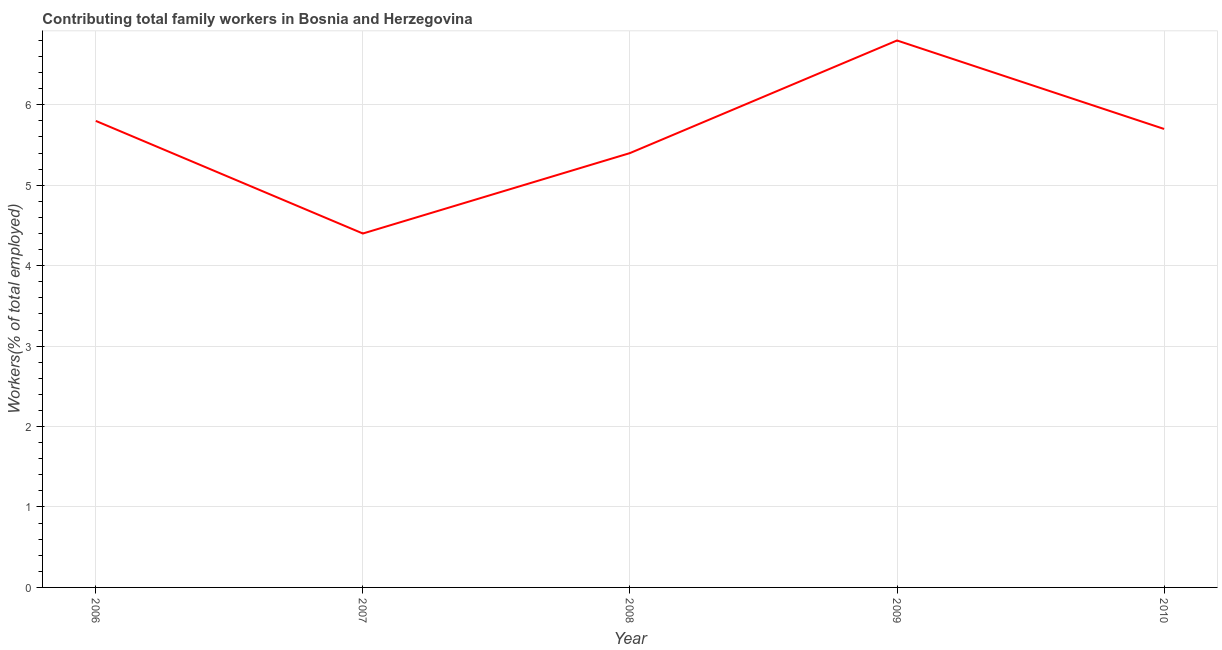What is the contributing family workers in 2006?
Ensure brevity in your answer.  5.8. Across all years, what is the maximum contributing family workers?
Your answer should be compact. 6.8. Across all years, what is the minimum contributing family workers?
Ensure brevity in your answer.  4.4. In which year was the contributing family workers maximum?
Keep it short and to the point. 2009. In which year was the contributing family workers minimum?
Your answer should be compact. 2007. What is the sum of the contributing family workers?
Keep it short and to the point. 28.1. What is the average contributing family workers per year?
Offer a very short reply. 5.62. What is the median contributing family workers?
Your response must be concise. 5.7. In how many years, is the contributing family workers greater than 1 %?
Your answer should be compact. 5. Do a majority of the years between 2009 and 2010 (inclusive) have contributing family workers greater than 0.6000000000000001 %?
Give a very brief answer. Yes. What is the ratio of the contributing family workers in 2008 to that in 2009?
Give a very brief answer. 0.79. Is the contributing family workers in 2007 less than that in 2009?
Give a very brief answer. Yes. Is the difference between the contributing family workers in 2006 and 2008 greater than the difference between any two years?
Your response must be concise. No. What is the difference between the highest and the lowest contributing family workers?
Provide a succinct answer. 2.4. Does the contributing family workers monotonically increase over the years?
Your response must be concise. No. How many years are there in the graph?
Provide a short and direct response. 5. Does the graph contain any zero values?
Give a very brief answer. No. Does the graph contain grids?
Offer a terse response. Yes. What is the title of the graph?
Keep it short and to the point. Contributing total family workers in Bosnia and Herzegovina. What is the label or title of the X-axis?
Provide a succinct answer. Year. What is the label or title of the Y-axis?
Offer a very short reply. Workers(% of total employed). What is the Workers(% of total employed) of 2006?
Make the answer very short. 5.8. What is the Workers(% of total employed) in 2007?
Provide a short and direct response. 4.4. What is the Workers(% of total employed) of 2008?
Your response must be concise. 5.4. What is the Workers(% of total employed) in 2009?
Provide a short and direct response. 6.8. What is the Workers(% of total employed) of 2010?
Offer a very short reply. 5.7. What is the difference between the Workers(% of total employed) in 2006 and 2007?
Provide a succinct answer. 1.4. What is the difference between the Workers(% of total employed) in 2006 and 2008?
Provide a short and direct response. 0.4. What is the difference between the Workers(% of total employed) in 2006 and 2009?
Provide a short and direct response. -1. What is the difference between the Workers(% of total employed) in 2006 and 2010?
Keep it short and to the point. 0.1. What is the difference between the Workers(% of total employed) in 2007 and 2008?
Offer a terse response. -1. What is the difference between the Workers(% of total employed) in 2007 and 2009?
Provide a short and direct response. -2.4. What is the difference between the Workers(% of total employed) in 2007 and 2010?
Provide a short and direct response. -1.3. What is the ratio of the Workers(% of total employed) in 2006 to that in 2007?
Your response must be concise. 1.32. What is the ratio of the Workers(% of total employed) in 2006 to that in 2008?
Offer a very short reply. 1.07. What is the ratio of the Workers(% of total employed) in 2006 to that in 2009?
Ensure brevity in your answer.  0.85. What is the ratio of the Workers(% of total employed) in 2006 to that in 2010?
Offer a terse response. 1.02. What is the ratio of the Workers(% of total employed) in 2007 to that in 2008?
Your answer should be very brief. 0.81. What is the ratio of the Workers(% of total employed) in 2007 to that in 2009?
Your answer should be compact. 0.65. What is the ratio of the Workers(% of total employed) in 2007 to that in 2010?
Ensure brevity in your answer.  0.77. What is the ratio of the Workers(% of total employed) in 2008 to that in 2009?
Ensure brevity in your answer.  0.79. What is the ratio of the Workers(% of total employed) in 2008 to that in 2010?
Keep it short and to the point. 0.95. What is the ratio of the Workers(% of total employed) in 2009 to that in 2010?
Your answer should be compact. 1.19. 